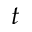Convert formula to latex. <formula><loc_0><loc_0><loc_500><loc_500>t</formula> 